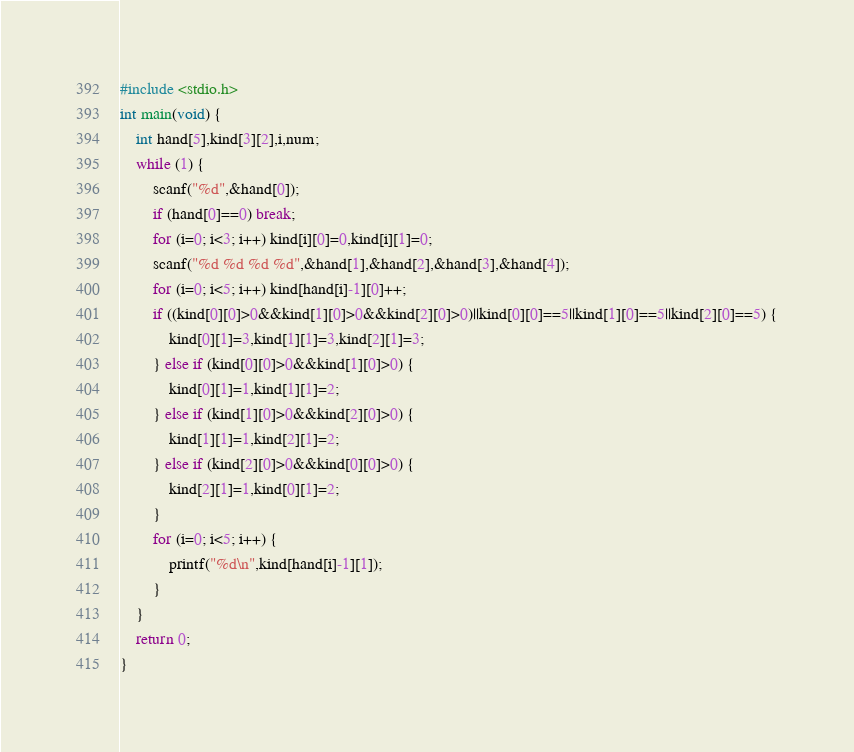Convert code to text. <code><loc_0><loc_0><loc_500><loc_500><_C_>#include <stdio.h>
int main(void) {
    int hand[5],kind[3][2],i,num;
    while (1) {
        scanf("%d",&hand[0]);
        if (hand[0]==0) break;
        for (i=0; i<3; i++) kind[i][0]=0,kind[i][1]=0;
        scanf("%d %d %d %d",&hand[1],&hand[2],&hand[3],&hand[4]);
        for (i=0; i<5; i++) kind[hand[i]-1][0]++;
        if ((kind[0][0]>0&&kind[1][0]>0&&kind[2][0]>0)||kind[0][0]==5||kind[1][0]==5||kind[2][0]==5) {
            kind[0][1]=3,kind[1][1]=3,kind[2][1]=3;
        } else if (kind[0][0]>0&&kind[1][0]>0) {
            kind[0][1]=1,kind[1][1]=2;
        } else if (kind[1][0]>0&&kind[2][0]>0) {
            kind[1][1]=1,kind[2][1]=2;
        } else if (kind[2][0]>0&&kind[0][0]>0) {
            kind[2][1]=1,kind[0][1]=2;
        }
        for (i=0; i<5; i++) {
            printf("%d\n",kind[hand[i]-1][1]);
        }
    }
    return 0;
}</code> 